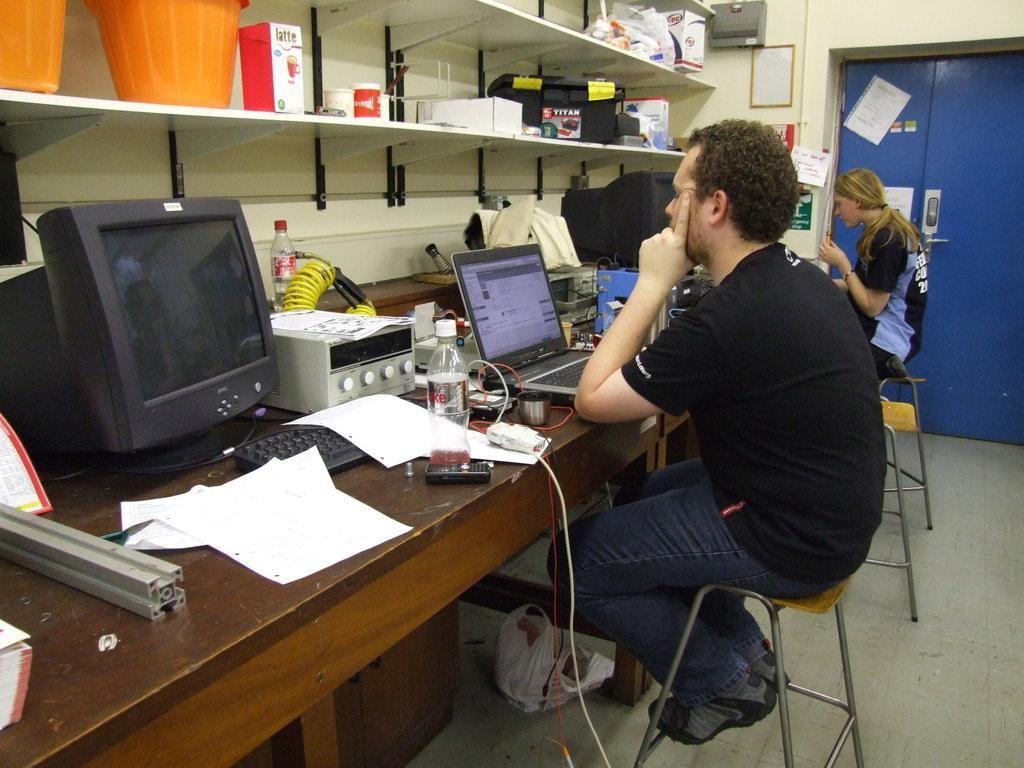How many people are in the image? There are two persons in the image. What are the persons doing in the image? The persons are sitting on stools. What is in front of the persons? There is a table in front of the persons. What electronic devices can be seen on the table? There are laptops and desktops on the table. Are there any other objects on the table? Yes, there are other objects on the table. What type of muscle can be seen flexing on the table? There is no muscle present in the image; it features two persons sitting on stools with laptops and desktops on a table. 